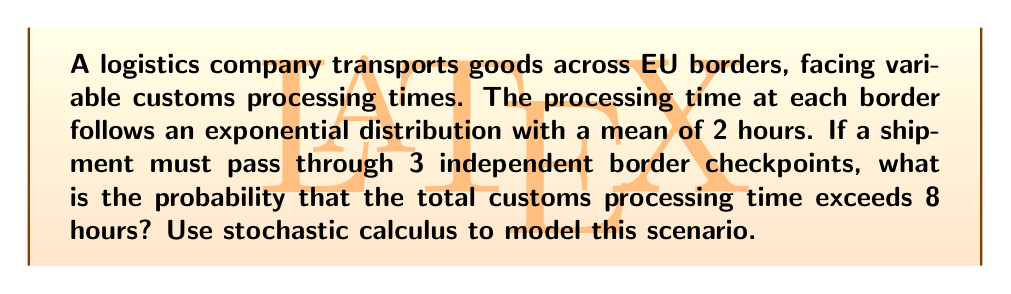Could you help me with this problem? Let's approach this step-by-step:

1) First, we need to understand the properties of the exponential distribution. The probability density function of an exponential distribution with rate parameter $\lambda$ is:

   $$f(x) = \lambda e^{-\lambda x}, \quad x \geq 0$$

2) Given that the mean processing time is 2 hours, we can determine $\lambda$:

   $$E[X] = \frac{1}{\lambda} = 2$$
   $$\lambda = \frac{1}{2}$$

3) Now, we're dealing with the sum of three independent exponential distributions. The sum of independent exponential distributions with the same rate parameter follows an Erlang distribution.

4) The Erlang distribution with shape parameter $k$ (number of exponential distributions summed) and rate parameter $\lambda$ has the following cumulative distribution function:

   $$F(x; k, \lambda) = 1 - e^{-\lambda x} \sum_{n=0}^{k-1} \frac{(\lambda x)^n}{n!}$$

5) In our case, $k = 3$ and $\lambda = \frac{1}{2}$. We want to find $P(X > 8)$, which is equivalent to $1 - P(X \leq 8)$:

   $$P(X > 8) = 1 - F(8; 3, \frac{1}{2})$$

6) Substituting into the Erlang CDF:

   $$P(X > 8) = 1 - (1 - e^{-4} (1 + 4 + \frac{4^2}{2}))$$

7) Simplifying:

   $$P(X > 8) = e^{-4} (1 + 4 + 8)$$
   $$P(X > 8) = 13e^{-4}$$

8) Calculating this value:

   $$P(X > 8) \approx 0.0432$$
Answer: $0.0432$ or $4.32\%$ 